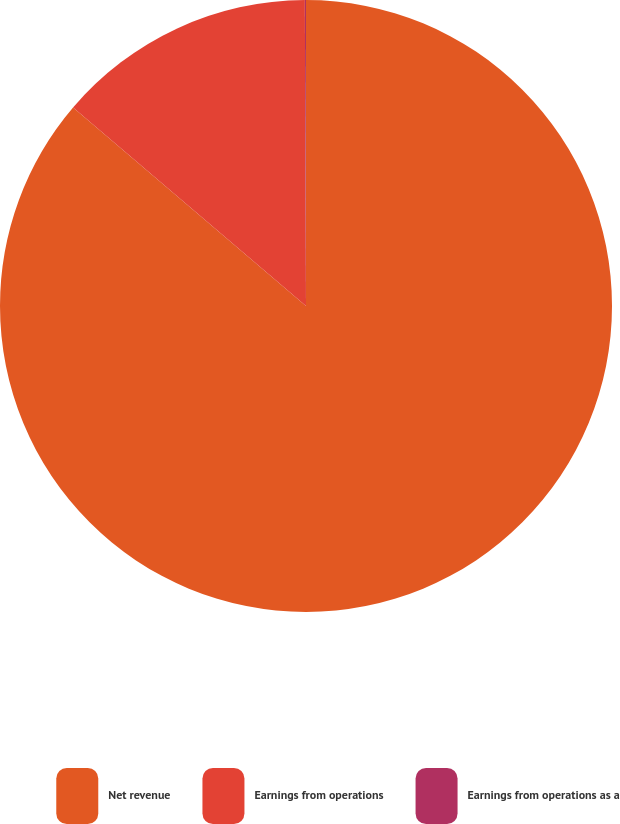Convert chart. <chart><loc_0><loc_0><loc_500><loc_500><pie_chart><fcel>Net revenue<fcel>Earnings from operations<fcel>Earnings from operations as a<nl><fcel>86.23%<fcel>13.71%<fcel>0.06%<nl></chart> 